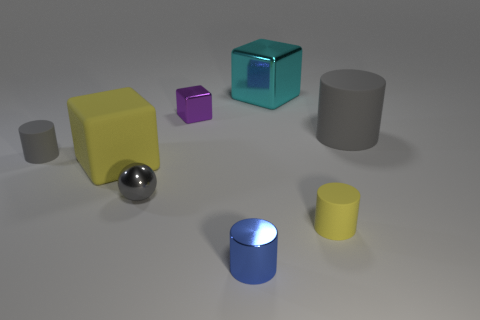The gray rubber thing that is in front of the large matte thing right of the tiny metal object that is right of the tiny purple object is what shape?
Give a very brief answer. Cylinder. There is a matte thing to the left of the yellow cube; does it have the same color as the large cube behind the large rubber cylinder?
Ensure brevity in your answer.  No. Are there any big matte cylinders right of the tiny shiny ball?
Ensure brevity in your answer.  Yes. How many tiny rubber objects are the same shape as the blue metal thing?
Offer a terse response. 2. The tiny cylinder that is to the right of the large cube behind the tiny object to the left of the gray shiny object is what color?
Offer a terse response. Yellow. Are the large block that is behind the purple object and the yellow block that is to the left of the tiny yellow rubber cylinder made of the same material?
Offer a terse response. No. What number of things are either matte cylinders that are behind the small gray metal sphere or large gray matte objects?
Provide a succinct answer. 2. How many things are either small red blocks or things that are in front of the small gray matte cylinder?
Offer a terse response. 4. What number of gray rubber cylinders are the same size as the cyan object?
Keep it short and to the point. 1. Are there fewer tiny blocks that are on the right side of the tiny gray ball than cylinders in front of the big yellow matte cube?
Ensure brevity in your answer.  Yes. 